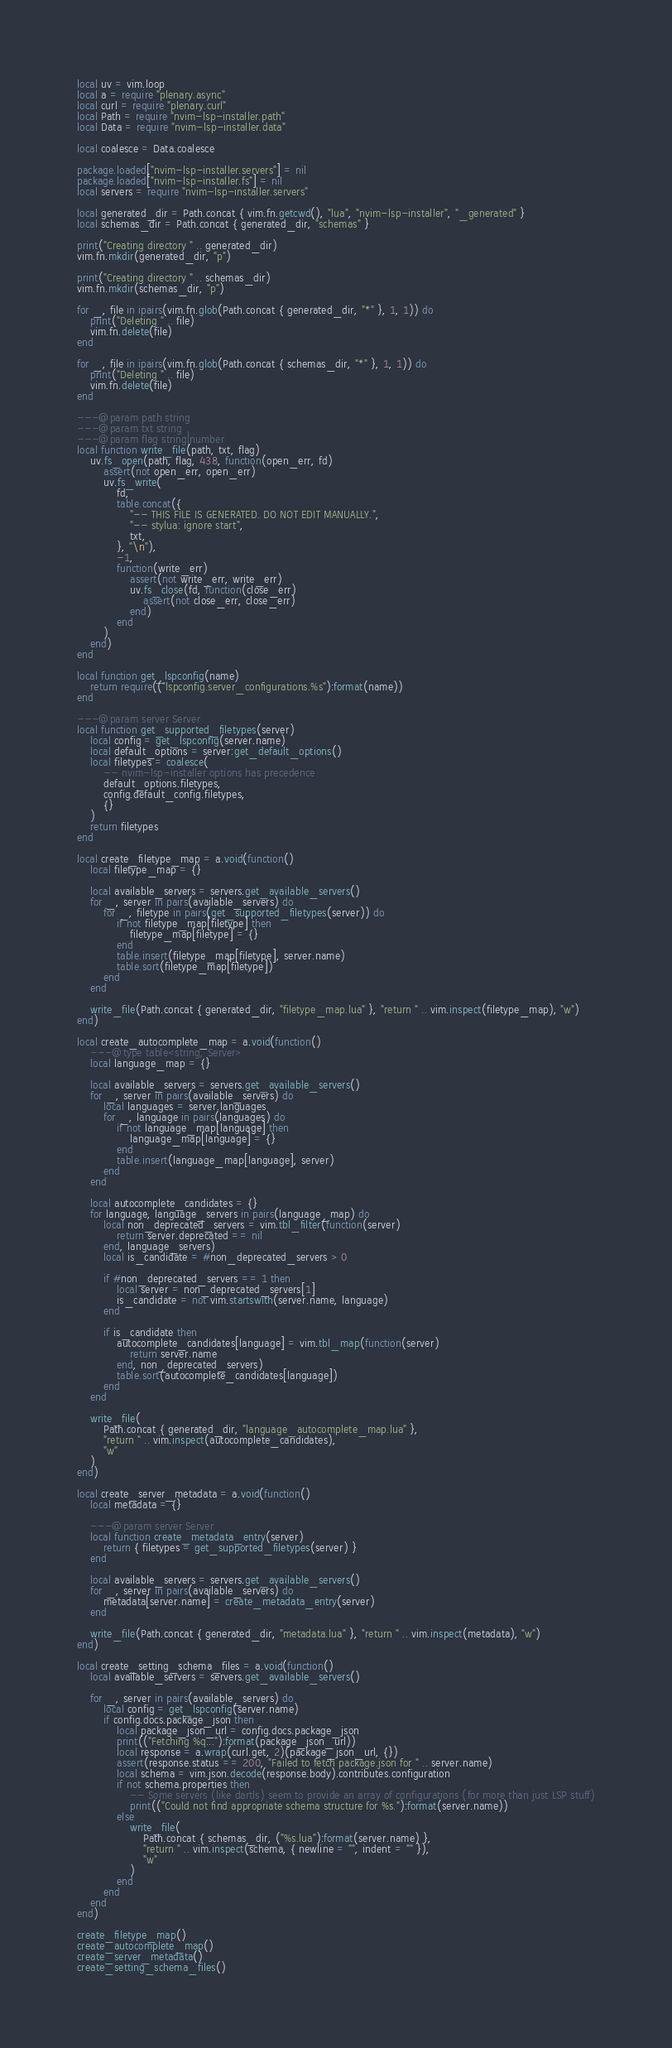<code> <loc_0><loc_0><loc_500><loc_500><_Lua_>local uv = vim.loop
local a = require "plenary.async"
local curl = require "plenary.curl"
local Path = require "nvim-lsp-installer.path"
local Data = require "nvim-lsp-installer.data"

local coalesce = Data.coalesce

package.loaded["nvim-lsp-installer.servers"] = nil
package.loaded["nvim-lsp-installer.fs"] = nil
local servers = require "nvim-lsp-installer.servers"

local generated_dir = Path.concat { vim.fn.getcwd(), "lua", "nvim-lsp-installer", "_generated" }
local schemas_dir = Path.concat { generated_dir, "schemas" }

print("Creating directory " .. generated_dir)
vim.fn.mkdir(generated_dir, "p")

print("Creating directory " .. schemas_dir)
vim.fn.mkdir(schemas_dir, "p")

for _, file in ipairs(vim.fn.glob(Path.concat { generated_dir, "*" }, 1, 1)) do
    print("Deleting " .. file)
    vim.fn.delete(file)
end

for _, file in ipairs(vim.fn.glob(Path.concat { schemas_dir, "*" }, 1, 1)) do
    print("Deleting " .. file)
    vim.fn.delete(file)
end

---@param path string
---@param txt string
---@param flag string|number
local function write_file(path, txt, flag)
    uv.fs_open(path, flag, 438, function(open_err, fd)
        assert(not open_err, open_err)
        uv.fs_write(
            fd,
            table.concat({
                "-- THIS FILE IS GENERATED. DO NOT EDIT MANUALLY.",
                "-- stylua: ignore start",
                txt,
            }, "\n"),
            -1,
            function(write_err)
                assert(not write_err, write_err)
                uv.fs_close(fd, function(close_err)
                    assert(not close_err, close_err)
                end)
            end
        )
    end)
end

local function get_lspconfig(name)
    return require(("lspconfig.server_configurations.%s"):format(name))
end

---@param server Server
local function get_supported_filetypes(server)
    local config = get_lspconfig(server.name)
    local default_options = server:get_default_options()
    local filetypes = coalesce(
        -- nvim-lsp-installer options has precedence
        default_options.filetypes,
        config.default_config.filetypes,
        {}
    )
    return filetypes
end

local create_filetype_map = a.void(function()
    local filetype_map = {}

    local available_servers = servers.get_available_servers()
    for _, server in pairs(available_servers) do
        for _, filetype in pairs(get_supported_filetypes(server)) do
            if not filetype_map[filetype] then
                filetype_map[filetype] = {}
            end
            table.insert(filetype_map[filetype], server.name)
            table.sort(filetype_map[filetype])
        end
    end

    write_file(Path.concat { generated_dir, "filetype_map.lua" }, "return " .. vim.inspect(filetype_map), "w")
end)

local create_autocomplete_map = a.void(function()
    ---@type table<string, Server>
    local language_map = {}

    local available_servers = servers.get_available_servers()
    for _, server in pairs(available_servers) do
        local languages = server.languages
        for _, language in pairs(languages) do
            if not language_map[language] then
                language_map[language] = {}
            end
            table.insert(language_map[language], server)
        end
    end

    local autocomplete_candidates = {}
    for language, language_servers in pairs(language_map) do
        local non_deprecated_servers = vim.tbl_filter(function(server)
            return server.deprecated == nil
        end, language_servers)
        local is_candidate = #non_deprecated_servers > 0

        if #non_deprecated_servers == 1 then
            local server = non_deprecated_servers[1]
            is_candidate = not vim.startswith(server.name, language)
        end

        if is_candidate then
            autocomplete_candidates[language] = vim.tbl_map(function(server)
                return server.name
            end, non_deprecated_servers)
            table.sort(autocomplete_candidates[language])
        end
    end

    write_file(
        Path.concat { generated_dir, "language_autocomplete_map.lua" },
        "return " .. vim.inspect(autocomplete_candidates),
        "w"
    )
end)

local create_server_metadata = a.void(function()
    local metadata = {}

    ---@param server Server
    local function create_metadata_entry(server)
        return { filetypes = get_supported_filetypes(server) }
    end

    local available_servers = servers.get_available_servers()
    for _, server in pairs(available_servers) do
        metadata[server.name] = create_metadata_entry(server)
    end

    write_file(Path.concat { generated_dir, "metadata.lua" }, "return " .. vim.inspect(metadata), "w")
end)

local create_setting_schema_files = a.void(function()
    local available_servers = servers.get_available_servers()

    for _, server in pairs(available_servers) do
        local config = get_lspconfig(server.name)
        if config.docs.package_json then
            local package_json_url = config.docs.package_json
            print(("Fetching %q..."):format(package_json_url))
            local response = a.wrap(curl.get, 2)(package_json_url, {})
            assert(response.status == 200, "Failed to fetch package.json for " .. server.name)
            local schema = vim.json.decode(response.body).contributes.configuration
            if not schema.properties then
                -- Some servers (like dartls) seem to provide an array of configurations (for more than just LSP stuff)
                print(("Could not find appropriate schema structure for %s."):format(server.name))
            else
                write_file(
                    Path.concat { schemas_dir, ("%s.lua"):format(server.name) },
                    "return " .. vim.inspect(schema, { newline = "", indent = "" }),
                    "w"
                )
            end
        end
    end
end)

create_filetype_map()
create_autocomplete_map()
create_server_metadata()
create_setting_schema_files()
</code> 